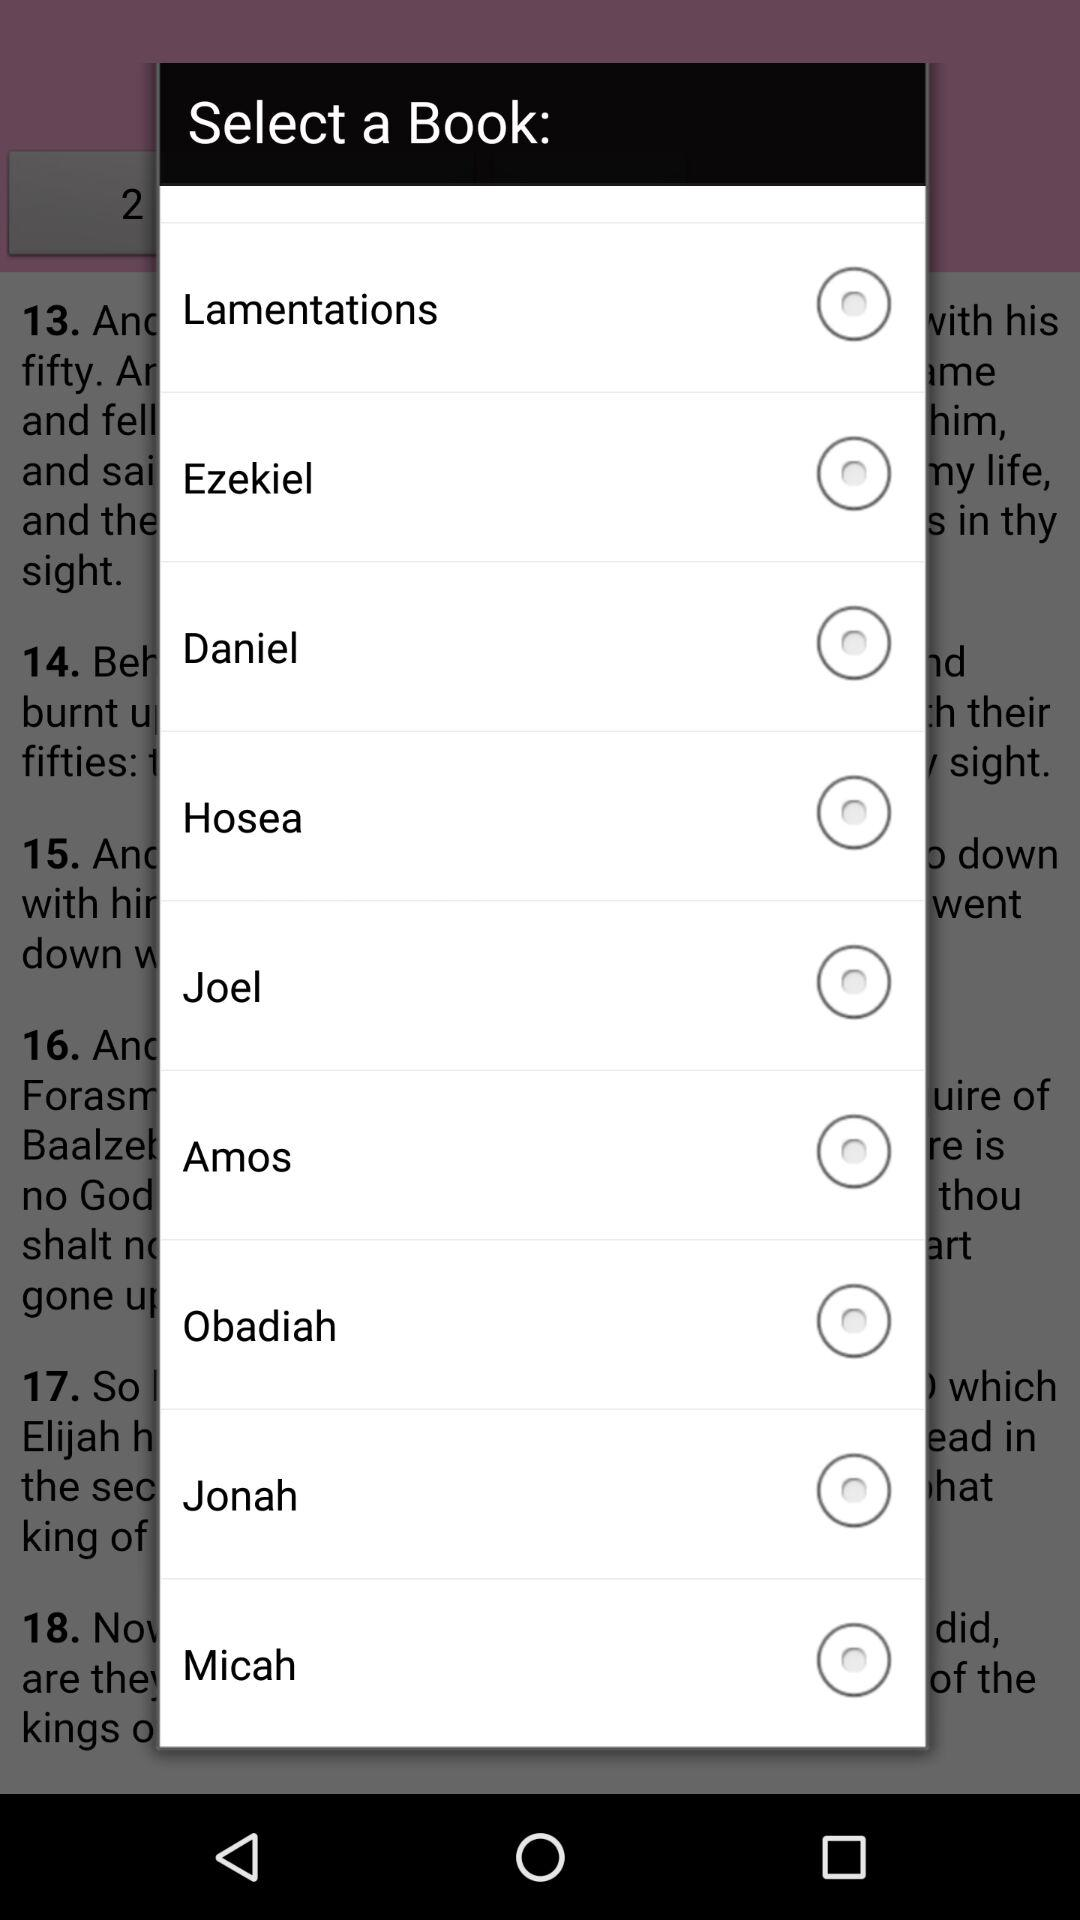What are the different books available? The different books available are: "Lamentations", "Ezekiel", "Daniel", "Hosea", "Joel", "Amos", "Obadiah", "Jonah", and "Micah". 